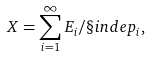Convert formula to latex. <formula><loc_0><loc_0><loc_500><loc_500>X = \sum _ { i = 1 } ^ { \infty } E _ { i } / \S i n d e p _ { i } ,</formula> 